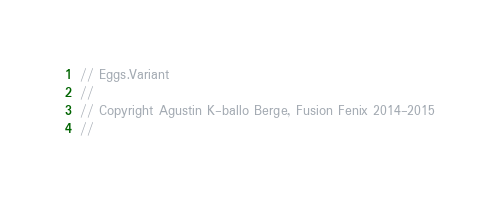Convert code to text. <code><loc_0><loc_0><loc_500><loc_500><_C++_>// Eggs.Variant
//
// Copyright Agustin K-ballo Berge, Fusion Fenix 2014-2015
//</code> 